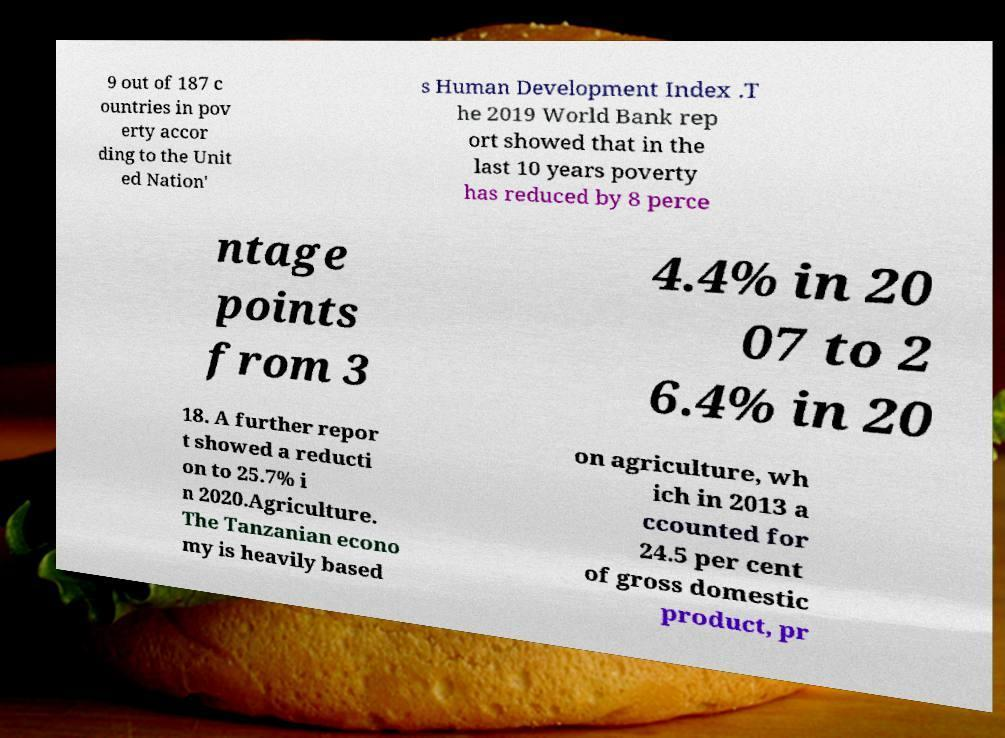Can you read and provide the text displayed in the image?This photo seems to have some interesting text. Can you extract and type it out for me? 9 out of 187 c ountries in pov erty accor ding to the Unit ed Nation' s Human Development Index .T he 2019 World Bank rep ort showed that in the last 10 years poverty has reduced by 8 perce ntage points from 3 4.4% in 20 07 to 2 6.4% in 20 18. A further repor t showed a reducti on to 25.7% i n 2020.Agriculture. The Tanzanian econo my is heavily based on agriculture, wh ich in 2013 a ccounted for 24.5 per cent of gross domestic product, pr 